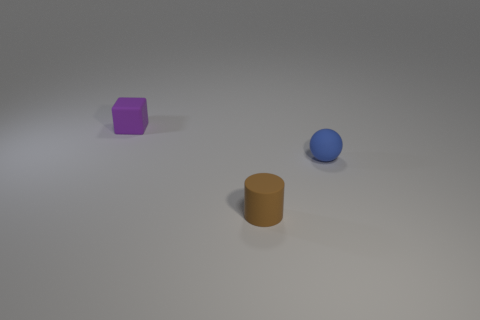Add 3 small gray metallic objects. How many objects exist? 6 Subtract all cubes. How many objects are left? 2 Add 2 purple cubes. How many purple cubes are left? 3 Add 3 large cyan shiny blocks. How many large cyan shiny blocks exist? 3 Subtract 0 yellow cylinders. How many objects are left? 3 Subtract all large purple metallic things. Subtract all blue rubber objects. How many objects are left? 2 